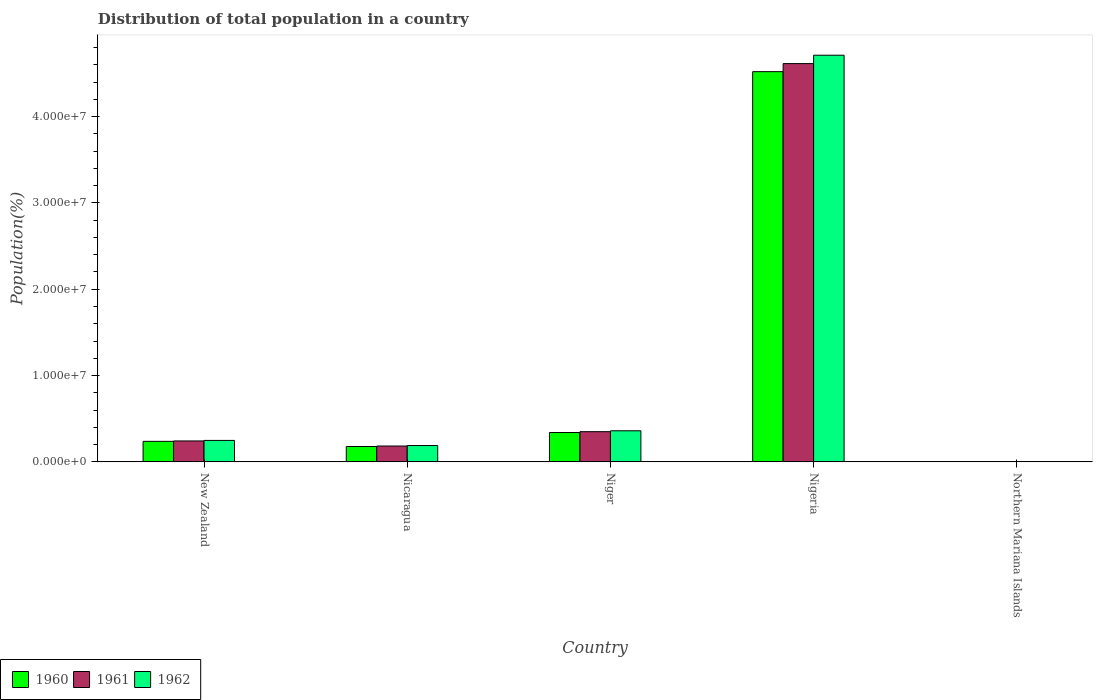How many different coloured bars are there?
Offer a very short reply. 3. How many groups of bars are there?
Provide a short and direct response. 5. What is the label of the 2nd group of bars from the left?
Give a very brief answer. Nicaragua. In how many cases, is the number of bars for a given country not equal to the number of legend labels?
Keep it short and to the point. 0. What is the population of in 1962 in New Zealand?
Make the answer very short. 2.48e+06. Across all countries, what is the maximum population of in 1960?
Provide a short and direct response. 4.52e+07. Across all countries, what is the minimum population of in 1962?
Your answer should be compact. 1.05e+04. In which country was the population of in 1960 maximum?
Ensure brevity in your answer.  Nigeria. In which country was the population of in 1962 minimum?
Provide a succinct answer. Northern Mariana Islands. What is the total population of in 1961 in the graph?
Your answer should be very brief. 5.39e+07. What is the difference between the population of in 1962 in New Zealand and that in Northern Mariana Islands?
Provide a succinct answer. 2.47e+06. What is the difference between the population of in 1962 in Nigeria and the population of in 1961 in New Zealand?
Your answer should be compact. 4.47e+07. What is the average population of in 1961 per country?
Your response must be concise. 1.08e+07. What is the difference between the population of of/in 1962 and population of of/in 1960 in New Zealand?
Provide a short and direct response. 1.10e+05. What is the ratio of the population of in 1961 in New Zealand to that in Nicaragua?
Keep it short and to the point. 1.32. What is the difference between the highest and the second highest population of in 1961?
Your response must be concise. 4.27e+07. What is the difference between the highest and the lowest population of in 1960?
Give a very brief answer. 4.52e+07. Is the sum of the population of in 1960 in Nigeria and Northern Mariana Islands greater than the maximum population of in 1961 across all countries?
Ensure brevity in your answer.  No. Is it the case that in every country, the sum of the population of in 1961 and population of in 1962 is greater than the population of in 1960?
Provide a succinct answer. Yes. How many bars are there?
Provide a short and direct response. 15. How many countries are there in the graph?
Your response must be concise. 5. What is the difference between two consecutive major ticks on the Y-axis?
Give a very brief answer. 1.00e+07. Does the graph contain any zero values?
Your response must be concise. No. Where does the legend appear in the graph?
Your response must be concise. Bottom left. How many legend labels are there?
Your answer should be very brief. 3. How are the legend labels stacked?
Offer a terse response. Horizontal. What is the title of the graph?
Provide a succinct answer. Distribution of total population in a country. Does "1986" appear as one of the legend labels in the graph?
Your answer should be compact. No. What is the label or title of the X-axis?
Provide a short and direct response. Country. What is the label or title of the Y-axis?
Ensure brevity in your answer.  Population(%). What is the Population(%) in 1960 in New Zealand?
Provide a short and direct response. 2.37e+06. What is the Population(%) in 1961 in New Zealand?
Provide a succinct answer. 2.42e+06. What is the Population(%) in 1962 in New Zealand?
Offer a very short reply. 2.48e+06. What is the Population(%) in 1960 in Nicaragua?
Keep it short and to the point. 1.77e+06. What is the Population(%) of 1961 in Nicaragua?
Ensure brevity in your answer.  1.83e+06. What is the Population(%) of 1962 in Nicaragua?
Ensure brevity in your answer.  1.89e+06. What is the Population(%) of 1960 in Niger?
Make the answer very short. 3.40e+06. What is the Population(%) of 1961 in Niger?
Keep it short and to the point. 3.49e+06. What is the Population(%) in 1962 in Niger?
Your response must be concise. 3.60e+06. What is the Population(%) in 1960 in Nigeria?
Keep it short and to the point. 4.52e+07. What is the Population(%) of 1961 in Nigeria?
Your answer should be compact. 4.61e+07. What is the Population(%) in 1962 in Nigeria?
Your answer should be very brief. 4.71e+07. What is the Population(%) of 1960 in Northern Mariana Islands?
Make the answer very short. 1.01e+04. What is the Population(%) in 1961 in Northern Mariana Islands?
Provide a succinct answer. 1.03e+04. What is the Population(%) of 1962 in Northern Mariana Islands?
Offer a terse response. 1.05e+04. Across all countries, what is the maximum Population(%) of 1960?
Your answer should be compact. 4.52e+07. Across all countries, what is the maximum Population(%) of 1961?
Ensure brevity in your answer.  4.61e+07. Across all countries, what is the maximum Population(%) in 1962?
Offer a terse response. 4.71e+07. Across all countries, what is the minimum Population(%) in 1960?
Make the answer very short. 1.01e+04. Across all countries, what is the minimum Population(%) in 1961?
Give a very brief answer. 1.03e+04. Across all countries, what is the minimum Population(%) in 1962?
Keep it short and to the point. 1.05e+04. What is the total Population(%) of 1960 in the graph?
Keep it short and to the point. 5.28e+07. What is the total Population(%) in 1961 in the graph?
Provide a succinct answer. 5.39e+07. What is the total Population(%) in 1962 in the graph?
Your answer should be very brief. 5.51e+07. What is the difference between the Population(%) of 1960 in New Zealand and that in Nicaragua?
Provide a short and direct response. 5.97e+05. What is the difference between the Population(%) of 1961 in New Zealand and that in Nicaragua?
Keep it short and to the point. 5.89e+05. What is the difference between the Population(%) in 1962 in New Zealand and that in Nicaragua?
Offer a terse response. 5.95e+05. What is the difference between the Population(%) of 1960 in New Zealand and that in Niger?
Provide a short and direct response. -1.02e+06. What is the difference between the Population(%) of 1961 in New Zealand and that in Niger?
Your answer should be compact. -1.07e+06. What is the difference between the Population(%) in 1962 in New Zealand and that in Niger?
Make the answer very short. -1.11e+06. What is the difference between the Population(%) of 1960 in New Zealand and that in Nigeria?
Keep it short and to the point. -4.28e+07. What is the difference between the Population(%) of 1961 in New Zealand and that in Nigeria?
Ensure brevity in your answer.  -4.37e+07. What is the difference between the Population(%) in 1962 in New Zealand and that in Nigeria?
Offer a terse response. -4.46e+07. What is the difference between the Population(%) in 1960 in New Zealand and that in Northern Mariana Islands?
Your response must be concise. 2.36e+06. What is the difference between the Population(%) of 1961 in New Zealand and that in Northern Mariana Islands?
Your answer should be compact. 2.41e+06. What is the difference between the Population(%) in 1962 in New Zealand and that in Northern Mariana Islands?
Ensure brevity in your answer.  2.47e+06. What is the difference between the Population(%) of 1960 in Nicaragua and that in Niger?
Give a very brief answer. -1.62e+06. What is the difference between the Population(%) in 1961 in Nicaragua and that in Niger?
Give a very brief answer. -1.66e+06. What is the difference between the Population(%) of 1962 in Nicaragua and that in Niger?
Make the answer very short. -1.71e+06. What is the difference between the Population(%) of 1960 in Nicaragua and that in Nigeria?
Keep it short and to the point. -4.34e+07. What is the difference between the Population(%) in 1961 in Nicaragua and that in Nigeria?
Your answer should be compact. -4.43e+07. What is the difference between the Population(%) in 1962 in Nicaragua and that in Nigeria?
Your answer should be very brief. -4.52e+07. What is the difference between the Population(%) in 1960 in Nicaragua and that in Northern Mariana Islands?
Offer a very short reply. 1.76e+06. What is the difference between the Population(%) of 1961 in Nicaragua and that in Northern Mariana Islands?
Keep it short and to the point. 1.82e+06. What is the difference between the Population(%) of 1962 in Nicaragua and that in Northern Mariana Islands?
Offer a terse response. 1.88e+06. What is the difference between the Population(%) of 1960 in Niger and that in Nigeria?
Offer a very short reply. -4.18e+07. What is the difference between the Population(%) of 1961 in Niger and that in Nigeria?
Keep it short and to the point. -4.27e+07. What is the difference between the Population(%) in 1962 in Niger and that in Nigeria?
Make the answer very short. -4.35e+07. What is the difference between the Population(%) of 1960 in Niger and that in Northern Mariana Islands?
Ensure brevity in your answer.  3.39e+06. What is the difference between the Population(%) in 1961 in Niger and that in Northern Mariana Islands?
Keep it short and to the point. 3.48e+06. What is the difference between the Population(%) in 1962 in Niger and that in Northern Mariana Islands?
Your response must be concise. 3.59e+06. What is the difference between the Population(%) of 1960 in Nigeria and that in Northern Mariana Islands?
Your response must be concise. 4.52e+07. What is the difference between the Population(%) of 1961 in Nigeria and that in Northern Mariana Islands?
Your answer should be very brief. 4.61e+07. What is the difference between the Population(%) of 1962 in Nigeria and that in Northern Mariana Islands?
Ensure brevity in your answer.  4.71e+07. What is the difference between the Population(%) in 1960 in New Zealand and the Population(%) in 1961 in Nicaragua?
Keep it short and to the point. 5.41e+05. What is the difference between the Population(%) of 1960 in New Zealand and the Population(%) of 1962 in Nicaragua?
Give a very brief answer. 4.85e+05. What is the difference between the Population(%) of 1961 in New Zealand and the Population(%) of 1962 in Nicaragua?
Offer a very short reply. 5.33e+05. What is the difference between the Population(%) in 1960 in New Zealand and the Population(%) in 1961 in Niger?
Offer a terse response. -1.12e+06. What is the difference between the Population(%) in 1960 in New Zealand and the Population(%) in 1962 in Niger?
Provide a succinct answer. -1.22e+06. What is the difference between the Population(%) in 1961 in New Zealand and the Population(%) in 1962 in Niger?
Your response must be concise. -1.18e+06. What is the difference between the Population(%) in 1960 in New Zealand and the Population(%) in 1961 in Nigeria?
Keep it short and to the point. -4.38e+07. What is the difference between the Population(%) in 1960 in New Zealand and the Population(%) in 1962 in Nigeria?
Your answer should be compact. -4.47e+07. What is the difference between the Population(%) of 1961 in New Zealand and the Population(%) of 1962 in Nigeria?
Provide a short and direct response. -4.47e+07. What is the difference between the Population(%) in 1960 in New Zealand and the Population(%) in 1961 in Northern Mariana Islands?
Give a very brief answer. 2.36e+06. What is the difference between the Population(%) in 1960 in New Zealand and the Population(%) in 1962 in Northern Mariana Islands?
Provide a succinct answer. 2.36e+06. What is the difference between the Population(%) in 1961 in New Zealand and the Population(%) in 1962 in Northern Mariana Islands?
Make the answer very short. 2.41e+06. What is the difference between the Population(%) of 1960 in Nicaragua and the Population(%) of 1961 in Niger?
Offer a terse response. -1.72e+06. What is the difference between the Population(%) in 1960 in Nicaragua and the Population(%) in 1962 in Niger?
Provide a short and direct response. -1.82e+06. What is the difference between the Population(%) of 1961 in Nicaragua and the Population(%) of 1962 in Niger?
Make the answer very short. -1.77e+06. What is the difference between the Population(%) of 1960 in Nicaragua and the Population(%) of 1961 in Nigeria?
Offer a terse response. -4.44e+07. What is the difference between the Population(%) in 1960 in Nicaragua and the Population(%) in 1962 in Nigeria?
Your answer should be compact. -4.53e+07. What is the difference between the Population(%) in 1961 in Nicaragua and the Population(%) in 1962 in Nigeria?
Give a very brief answer. -4.53e+07. What is the difference between the Population(%) in 1960 in Nicaragua and the Population(%) in 1961 in Northern Mariana Islands?
Make the answer very short. 1.76e+06. What is the difference between the Population(%) in 1960 in Nicaragua and the Population(%) in 1962 in Northern Mariana Islands?
Your response must be concise. 1.76e+06. What is the difference between the Population(%) in 1961 in Nicaragua and the Population(%) in 1962 in Northern Mariana Islands?
Your response must be concise. 1.82e+06. What is the difference between the Population(%) of 1960 in Niger and the Population(%) of 1961 in Nigeria?
Provide a succinct answer. -4.27e+07. What is the difference between the Population(%) in 1960 in Niger and the Population(%) in 1962 in Nigeria?
Keep it short and to the point. -4.37e+07. What is the difference between the Population(%) in 1961 in Niger and the Population(%) in 1962 in Nigeria?
Your response must be concise. -4.36e+07. What is the difference between the Population(%) in 1960 in Niger and the Population(%) in 1961 in Northern Mariana Islands?
Your answer should be very brief. 3.38e+06. What is the difference between the Population(%) of 1960 in Niger and the Population(%) of 1962 in Northern Mariana Islands?
Make the answer very short. 3.38e+06. What is the difference between the Population(%) of 1961 in Niger and the Population(%) of 1962 in Northern Mariana Islands?
Provide a short and direct response. 3.48e+06. What is the difference between the Population(%) of 1960 in Nigeria and the Population(%) of 1961 in Northern Mariana Islands?
Ensure brevity in your answer.  4.52e+07. What is the difference between the Population(%) of 1960 in Nigeria and the Population(%) of 1962 in Northern Mariana Islands?
Your response must be concise. 4.52e+07. What is the difference between the Population(%) of 1961 in Nigeria and the Population(%) of 1962 in Northern Mariana Islands?
Your response must be concise. 4.61e+07. What is the average Population(%) in 1960 per country?
Keep it short and to the point. 1.06e+07. What is the average Population(%) in 1961 per country?
Offer a very short reply. 1.08e+07. What is the average Population(%) in 1962 per country?
Ensure brevity in your answer.  1.10e+07. What is the difference between the Population(%) of 1960 and Population(%) of 1961 in New Zealand?
Offer a terse response. -4.79e+04. What is the difference between the Population(%) of 1960 and Population(%) of 1962 in New Zealand?
Your answer should be compact. -1.10e+05. What is the difference between the Population(%) of 1961 and Population(%) of 1962 in New Zealand?
Your answer should be very brief. -6.23e+04. What is the difference between the Population(%) in 1960 and Population(%) in 1961 in Nicaragua?
Ensure brevity in your answer.  -5.57e+04. What is the difference between the Population(%) of 1960 and Population(%) of 1962 in Nicaragua?
Make the answer very short. -1.12e+05. What is the difference between the Population(%) in 1961 and Population(%) in 1962 in Nicaragua?
Offer a terse response. -5.62e+04. What is the difference between the Population(%) of 1960 and Population(%) of 1961 in Niger?
Your answer should be very brief. -9.84e+04. What is the difference between the Population(%) of 1960 and Population(%) of 1962 in Niger?
Ensure brevity in your answer.  -2.01e+05. What is the difference between the Population(%) in 1961 and Population(%) in 1962 in Niger?
Give a very brief answer. -1.03e+05. What is the difference between the Population(%) of 1960 and Population(%) of 1961 in Nigeria?
Keep it short and to the point. -9.33e+05. What is the difference between the Population(%) in 1960 and Population(%) in 1962 in Nigeria?
Your answer should be very brief. -1.91e+06. What is the difference between the Population(%) in 1961 and Population(%) in 1962 in Nigeria?
Your response must be concise. -9.74e+05. What is the difference between the Population(%) in 1960 and Population(%) in 1961 in Northern Mariana Islands?
Give a very brief answer. -270. What is the difference between the Population(%) of 1960 and Population(%) of 1962 in Northern Mariana Islands?
Your response must be concise. -471. What is the difference between the Population(%) in 1961 and Population(%) in 1962 in Northern Mariana Islands?
Give a very brief answer. -201. What is the ratio of the Population(%) of 1960 in New Zealand to that in Nicaragua?
Your answer should be compact. 1.34. What is the ratio of the Population(%) of 1961 in New Zealand to that in Nicaragua?
Ensure brevity in your answer.  1.32. What is the ratio of the Population(%) in 1962 in New Zealand to that in Nicaragua?
Your response must be concise. 1.32. What is the ratio of the Population(%) of 1960 in New Zealand to that in Niger?
Keep it short and to the point. 0.7. What is the ratio of the Population(%) in 1961 in New Zealand to that in Niger?
Make the answer very short. 0.69. What is the ratio of the Population(%) of 1962 in New Zealand to that in Niger?
Provide a short and direct response. 0.69. What is the ratio of the Population(%) of 1960 in New Zealand to that in Nigeria?
Offer a very short reply. 0.05. What is the ratio of the Population(%) in 1961 in New Zealand to that in Nigeria?
Ensure brevity in your answer.  0.05. What is the ratio of the Population(%) in 1962 in New Zealand to that in Nigeria?
Give a very brief answer. 0.05. What is the ratio of the Population(%) of 1960 in New Zealand to that in Northern Mariana Islands?
Ensure brevity in your answer.  235.53. What is the ratio of the Population(%) in 1961 in New Zealand to that in Northern Mariana Islands?
Ensure brevity in your answer.  234.01. What is the ratio of the Population(%) of 1962 in New Zealand to that in Northern Mariana Islands?
Offer a terse response. 235.46. What is the ratio of the Population(%) of 1960 in Nicaragua to that in Niger?
Ensure brevity in your answer.  0.52. What is the ratio of the Population(%) of 1961 in Nicaragua to that in Niger?
Provide a short and direct response. 0.52. What is the ratio of the Population(%) of 1962 in Nicaragua to that in Niger?
Provide a short and direct response. 0.52. What is the ratio of the Population(%) of 1960 in Nicaragua to that in Nigeria?
Ensure brevity in your answer.  0.04. What is the ratio of the Population(%) of 1961 in Nicaragua to that in Nigeria?
Give a very brief answer. 0.04. What is the ratio of the Population(%) of 1960 in Nicaragua to that in Northern Mariana Islands?
Offer a very short reply. 176.24. What is the ratio of the Population(%) of 1961 in Nicaragua to that in Northern Mariana Islands?
Your answer should be very brief. 177.02. What is the ratio of the Population(%) of 1962 in Nicaragua to that in Northern Mariana Islands?
Your answer should be very brief. 178.97. What is the ratio of the Population(%) of 1960 in Niger to that in Nigeria?
Provide a short and direct response. 0.08. What is the ratio of the Population(%) in 1961 in Niger to that in Nigeria?
Offer a terse response. 0.08. What is the ratio of the Population(%) in 1962 in Niger to that in Nigeria?
Your answer should be very brief. 0.08. What is the ratio of the Population(%) in 1960 in Niger to that in Northern Mariana Islands?
Provide a short and direct response. 337.16. What is the ratio of the Population(%) of 1961 in Niger to that in Northern Mariana Islands?
Your response must be concise. 337.88. What is the ratio of the Population(%) of 1962 in Niger to that in Northern Mariana Islands?
Provide a succinct answer. 341.2. What is the ratio of the Population(%) of 1960 in Nigeria to that in Northern Mariana Islands?
Give a very brief answer. 4489.73. What is the ratio of the Population(%) in 1961 in Nigeria to that in Northern Mariana Islands?
Offer a very short reply. 4462.68. What is the ratio of the Population(%) in 1962 in Nigeria to that in Northern Mariana Islands?
Provide a succinct answer. 4469.96. What is the difference between the highest and the second highest Population(%) in 1960?
Provide a short and direct response. 4.18e+07. What is the difference between the highest and the second highest Population(%) of 1961?
Keep it short and to the point. 4.27e+07. What is the difference between the highest and the second highest Population(%) in 1962?
Provide a succinct answer. 4.35e+07. What is the difference between the highest and the lowest Population(%) in 1960?
Keep it short and to the point. 4.52e+07. What is the difference between the highest and the lowest Population(%) of 1961?
Your answer should be compact. 4.61e+07. What is the difference between the highest and the lowest Population(%) of 1962?
Ensure brevity in your answer.  4.71e+07. 